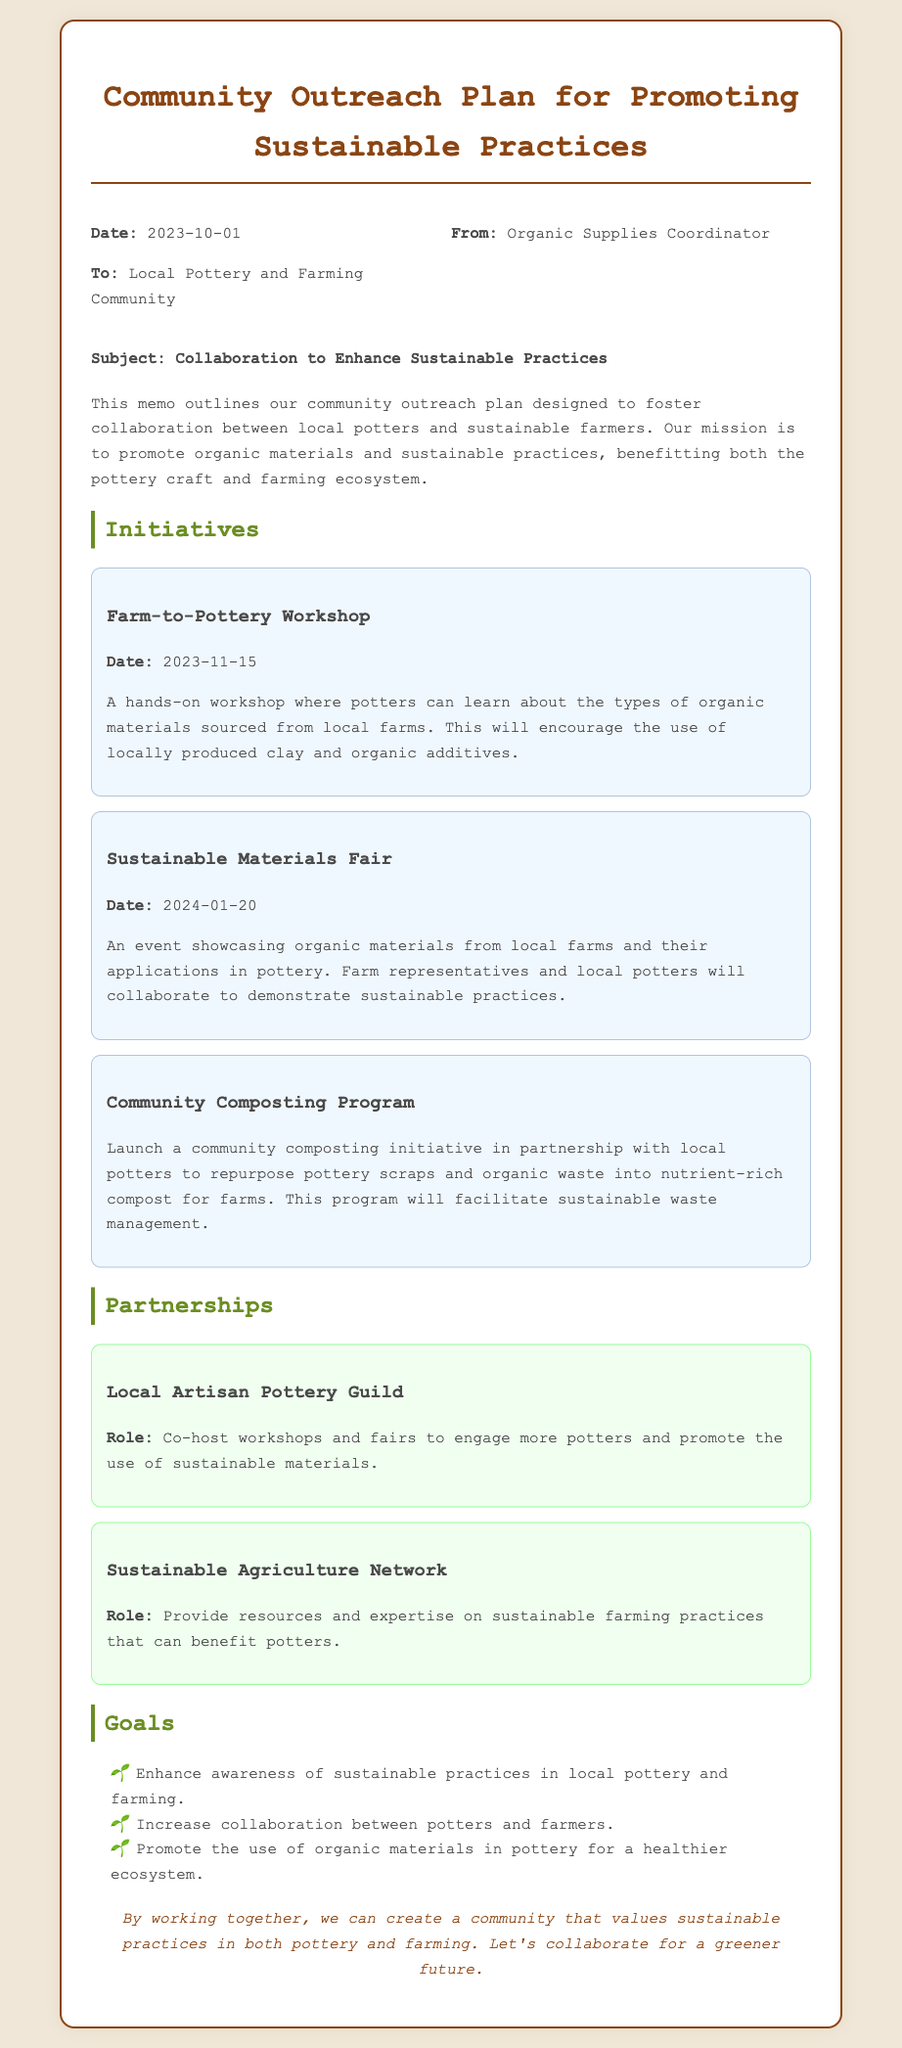What is the date of the Farm-to-Pottery Workshop? The date is specified in the initiatives section of the memo, indicating when the workshop will take place.
Answer: 2023-11-15 Who is the memo addressed to? The memo indicates the recipient in the header section, specifying the audience for this outreach plan.
Answer: Local Pottery and Farming Community What initiative showcases organic materials from local farms? The title of the initiative in the memo describes the event focusing on organic materials and pottery.
Answer: Sustainable Materials Fair Which organization is mentioned as a partner to co-host workshops? The partnership section details organizations collaborating in this outreach plan, specifically for workshops and fairs.
Answer: Local Artisan Pottery Guild What is one goal of the community outreach plan? The goals section lists objectives aimed at improving practices in pottery and farming, which can be directly referenced.
Answer: Enhance awareness of sustainable practices in local pottery and farming What type of program is being launched to manage waste? The initiative section describes the purpose and type of program aimed at sustainability and waste repurposing.
Answer: Community Composting Program What is the date of the Sustainable Materials Fair? The exact date is provided in the initiatives section to inform about this specific event.
Answer: 2024-01-20 Who will provide resources on sustainable farming practices? The partnership details who will assist in providing expertise for better practices within the community.
Answer: Sustainable Agriculture Network What is the role of the Sustainable Agriculture Network? The role of this partner is detailed in the partnership section describing their contribution in terms of resources.
Answer: Provide resources and expertise on sustainable farming practices that can benefit potters 